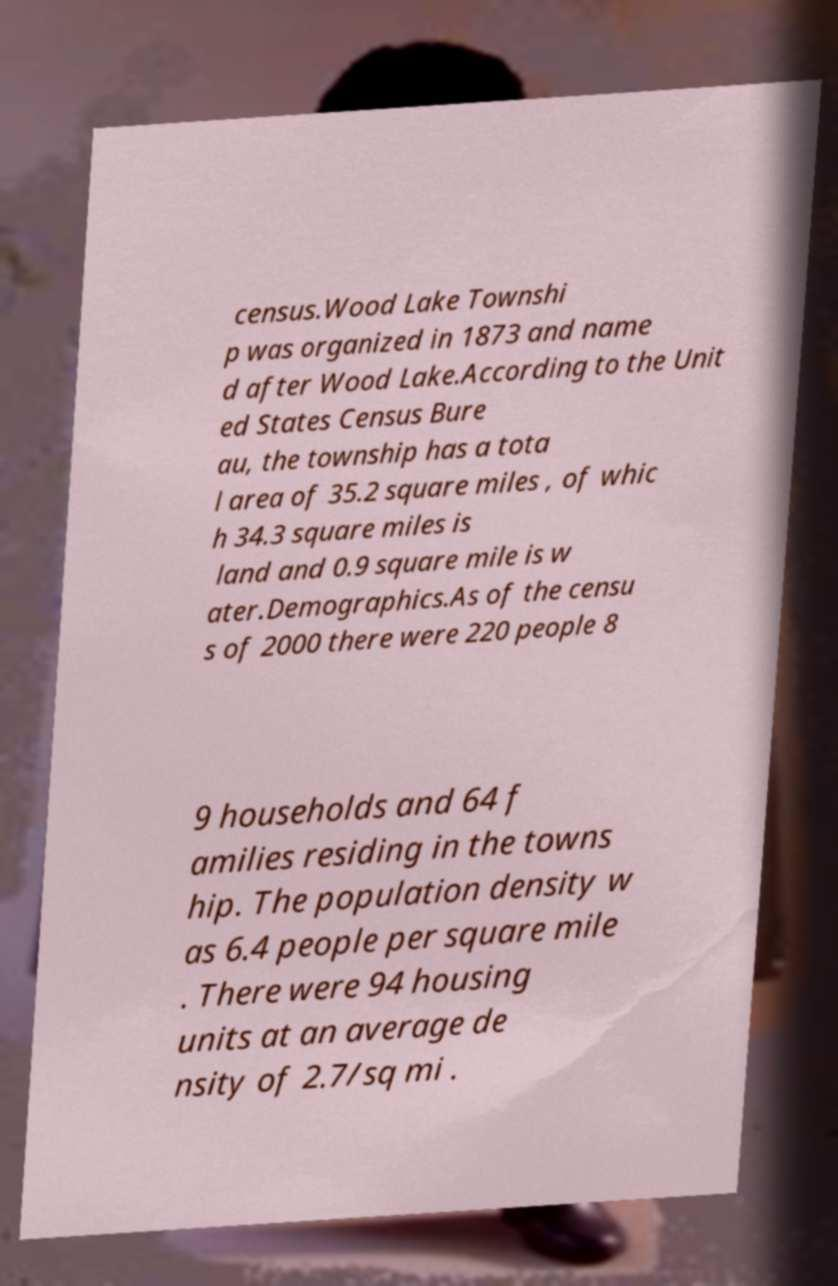Please identify and transcribe the text found in this image. census.Wood Lake Townshi p was organized in 1873 and name d after Wood Lake.According to the Unit ed States Census Bure au, the township has a tota l area of 35.2 square miles , of whic h 34.3 square miles is land and 0.9 square mile is w ater.Demographics.As of the censu s of 2000 there were 220 people 8 9 households and 64 f amilies residing in the towns hip. The population density w as 6.4 people per square mile . There were 94 housing units at an average de nsity of 2.7/sq mi . 